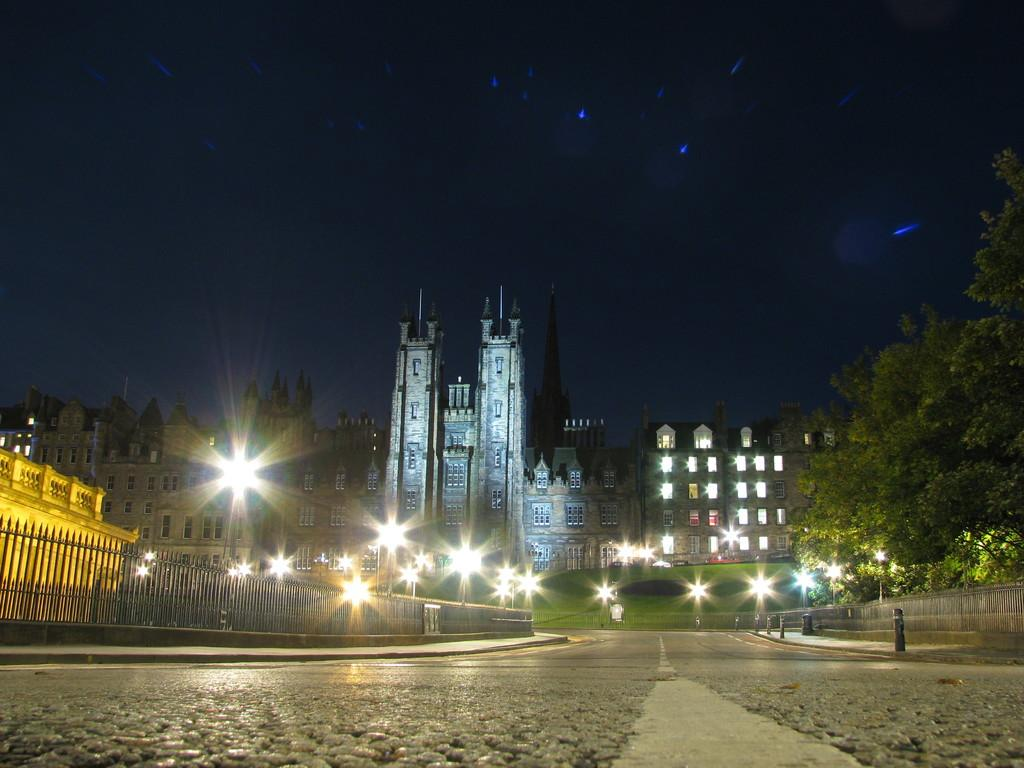What type of structures can be seen in the image? There are buildings in the image. What are the vertical objects in the image? There are poles in the image. What are the illuminated objects in the image? There are lights in the image. What type of vegetation is present in the image? There are trees and grass in the image. What architectural feature can be seen in the image? There are windows in the image. What type of barrier is present in the image? There is a fence in the image. What can be seen in the background of the image? The sky is visible in the background of the image. How many boys are playing with the dogs in the image? There are no boys or dogs present in the image. What type of vase is placed on the grass in the image? There is no vase present in the image. 